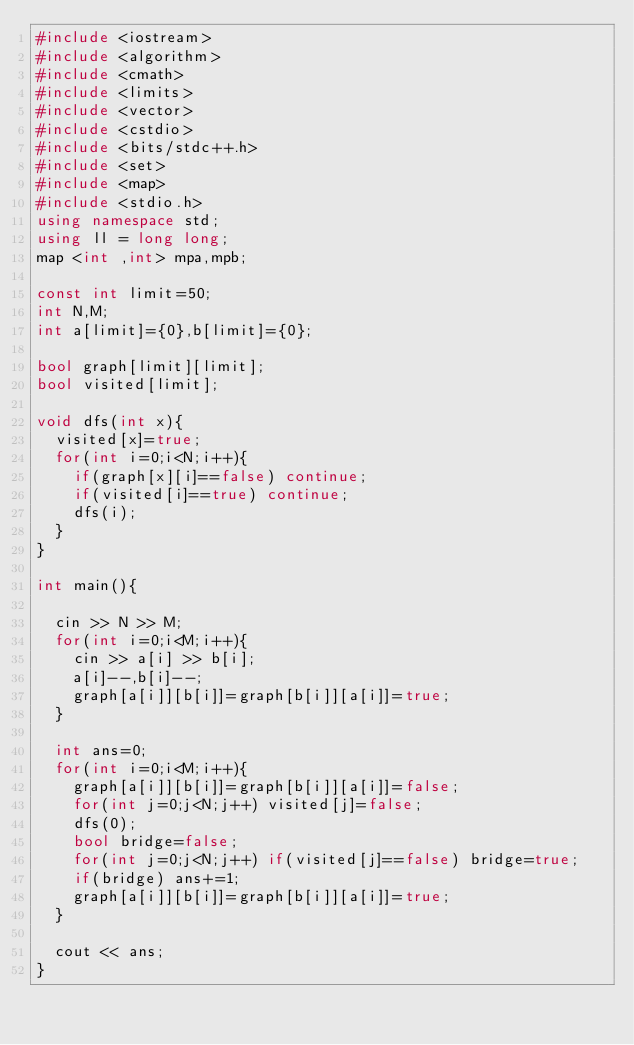Convert code to text. <code><loc_0><loc_0><loc_500><loc_500><_C++_>#include <iostream>
#include <algorithm>
#include <cmath>
#include <limits>
#include <vector>
#include <cstdio>
#include <bits/stdc++.h>
#include <set>
#include <map>
#include <stdio.h>
using namespace std;
using ll = long long;
map <int ,int> mpa,mpb;

const int limit=50;
int N,M;
int a[limit]={0},b[limit]={0};

bool graph[limit][limit];
bool visited[limit];

void dfs(int x){
  visited[x]=true;
  for(int i=0;i<N;i++){
    if(graph[x][i]==false) continue;
    if(visited[i]==true) continue;
    dfs(i);
  }
}

int main(){

  cin >> N >> M;
  for(int i=0;i<M;i++){
    cin >> a[i] >> b[i];
    a[i]--,b[i]--;
    graph[a[i]][b[i]]=graph[b[i]][a[i]]=true;
  }

  int ans=0;
  for(int i=0;i<M;i++){
    graph[a[i]][b[i]]=graph[b[i]][a[i]]=false;
    for(int j=0;j<N;j++) visited[j]=false;
    dfs(0);
    bool bridge=false;
    for(int j=0;j<N;j++) if(visited[j]==false) bridge=true;
    if(bridge) ans+=1;
    graph[a[i]][b[i]]=graph[b[i]][a[i]]=true;
  }

  cout << ans;
}</code> 